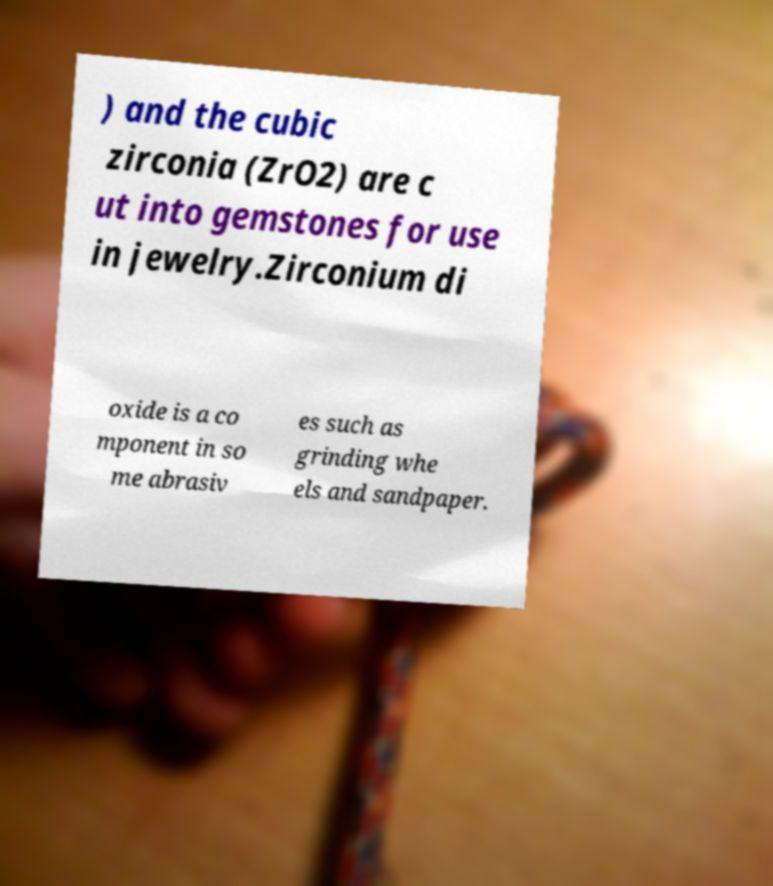Can you accurately transcribe the text from the provided image for me? ) and the cubic zirconia (ZrO2) are c ut into gemstones for use in jewelry.Zirconium di oxide is a co mponent in so me abrasiv es such as grinding whe els and sandpaper. 